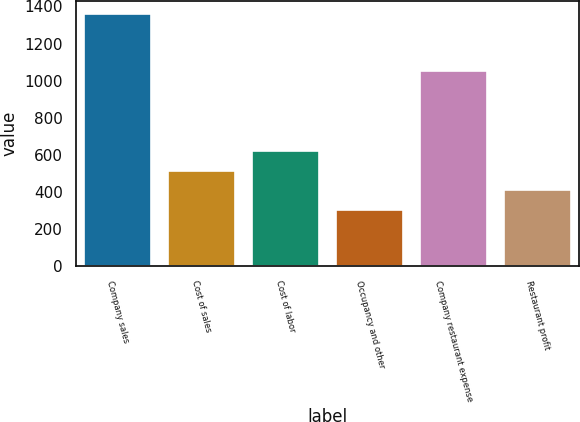Convert chart to OTSL. <chart><loc_0><loc_0><loc_500><loc_500><bar_chart><fcel>Company sales<fcel>Cost of sales<fcel>Cost of labor<fcel>Occupancy and other<fcel>Company restaurant expense<fcel>Restaurant profit<nl><fcel>1359<fcel>515<fcel>620.5<fcel>304<fcel>1054<fcel>409.5<nl></chart> 